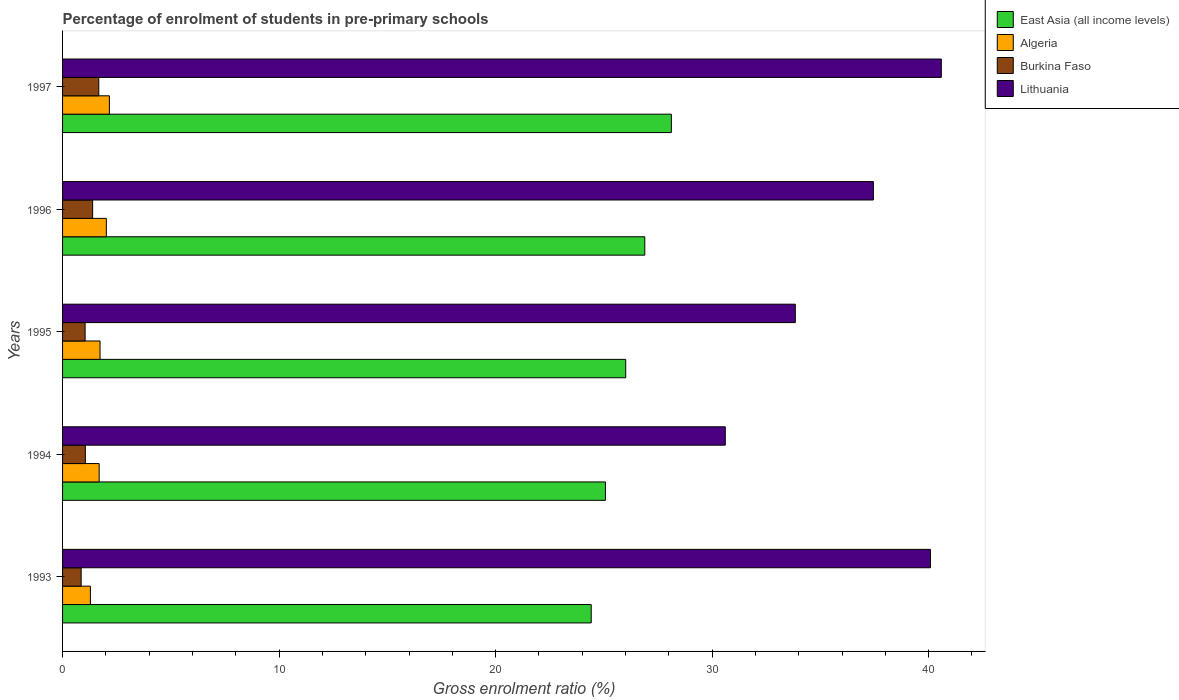How many bars are there on the 1st tick from the top?
Offer a terse response. 4. How many bars are there on the 1st tick from the bottom?
Make the answer very short. 4. What is the label of the 4th group of bars from the top?
Offer a terse response. 1994. In how many cases, is the number of bars for a given year not equal to the number of legend labels?
Offer a very short reply. 0. What is the percentage of students enrolled in pre-primary schools in Burkina Faso in 1994?
Make the answer very short. 1.05. Across all years, what is the maximum percentage of students enrolled in pre-primary schools in Lithuania?
Make the answer very short. 40.58. Across all years, what is the minimum percentage of students enrolled in pre-primary schools in Algeria?
Your response must be concise. 1.29. What is the total percentage of students enrolled in pre-primary schools in Lithuania in the graph?
Make the answer very short. 182.56. What is the difference between the percentage of students enrolled in pre-primary schools in Lithuania in 1995 and that in 1996?
Ensure brevity in your answer.  -3.61. What is the difference between the percentage of students enrolled in pre-primary schools in Algeria in 1996 and the percentage of students enrolled in pre-primary schools in Burkina Faso in 1997?
Offer a terse response. 0.35. What is the average percentage of students enrolled in pre-primary schools in Algeria per year?
Keep it short and to the point. 1.78. In the year 1994, what is the difference between the percentage of students enrolled in pre-primary schools in Burkina Faso and percentage of students enrolled in pre-primary schools in Algeria?
Your answer should be very brief. -0.64. What is the ratio of the percentage of students enrolled in pre-primary schools in Burkina Faso in 1995 to that in 1996?
Keep it short and to the point. 0.75. Is the percentage of students enrolled in pre-primary schools in Lithuania in 1994 less than that in 1996?
Give a very brief answer. Yes. Is the difference between the percentage of students enrolled in pre-primary schools in Burkina Faso in 1995 and 1997 greater than the difference between the percentage of students enrolled in pre-primary schools in Algeria in 1995 and 1997?
Your answer should be compact. No. What is the difference between the highest and the second highest percentage of students enrolled in pre-primary schools in Algeria?
Keep it short and to the point. 0.14. What is the difference between the highest and the lowest percentage of students enrolled in pre-primary schools in Lithuania?
Your response must be concise. 9.98. In how many years, is the percentage of students enrolled in pre-primary schools in Lithuania greater than the average percentage of students enrolled in pre-primary schools in Lithuania taken over all years?
Give a very brief answer. 3. Is the sum of the percentage of students enrolled in pre-primary schools in Burkina Faso in 1994 and 1995 greater than the maximum percentage of students enrolled in pre-primary schools in East Asia (all income levels) across all years?
Provide a succinct answer. No. What does the 3rd bar from the top in 1996 represents?
Ensure brevity in your answer.  Algeria. What does the 3rd bar from the bottom in 1994 represents?
Offer a very short reply. Burkina Faso. How many bars are there?
Give a very brief answer. 20. Does the graph contain any zero values?
Your answer should be very brief. No. Does the graph contain grids?
Your answer should be very brief. No. What is the title of the graph?
Your answer should be very brief. Percentage of enrolment of students in pre-primary schools. What is the Gross enrolment ratio (%) of East Asia (all income levels) in 1993?
Provide a succinct answer. 24.42. What is the Gross enrolment ratio (%) of Algeria in 1993?
Your answer should be very brief. 1.29. What is the Gross enrolment ratio (%) of Burkina Faso in 1993?
Your response must be concise. 0.86. What is the Gross enrolment ratio (%) in Lithuania in 1993?
Keep it short and to the point. 40.08. What is the Gross enrolment ratio (%) in East Asia (all income levels) in 1994?
Offer a very short reply. 25.07. What is the Gross enrolment ratio (%) in Algeria in 1994?
Your response must be concise. 1.69. What is the Gross enrolment ratio (%) in Burkina Faso in 1994?
Your answer should be very brief. 1.05. What is the Gross enrolment ratio (%) of Lithuania in 1994?
Offer a terse response. 30.61. What is the Gross enrolment ratio (%) in East Asia (all income levels) in 1995?
Provide a succinct answer. 26.01. What is the Gross enrolment ratio (%) in Algeria in 1995?
Give a very brief answer. 1.73. What is the Gross enrolment ratio (%) in Burkina Faso in 1995?
Your answer should be compact. 1.04. What is the Gross enrolment ratio (%) in Lithuania in 1995?
Provide a short and direct response. 33.84. What is the Gross enrolment ratio (%) in East Asia (all income levels) in 1996?
Provide a short and direct response. 26.89. What is the Gross enrolment ratio (%) of Algeria in 1996?
Provide a short and direct response. 2.02. What is the Gross enrolment ratio (%) of Burkina Faso in 1996?
Your answer should be compact. 1.39. What is the Gross enrolment ratio (%) of Lithuania in 1996?
Your answer should be very brief. 37.45. What is the Gross enrolment ratio (%) in East Asia (all income levels) in 1997?
Give a very brief answer. 28.12. What is the Gross enrolment ratio (%) in Algeria in 1997?
Offer a very short reply. 2.16. What is the Gross enrolment ratio (%) in Burkina Faso in 1997?
Offer a very short reply. 1.67. What is the Gross enrolment ratio (%) in Lithuania in 1997?
Provide a succinct answer. 40.58. Across all years, what is the maximum Gross enrolment ratio (%) of East Asia (all income levels)?
Provide a succinct answer. 28.12. Across all years, what is the maximum Gross enrolment ratio (%) of Algeria?
Make the answer very short. 2.16. Across all years, what is the maximum Gross enrolment ratio (%) in Burkina Faso?
Give a very brief answer. 1.67. Across all years, what is the maximum Gross enrolment ratio (%) of Lithuania?
Make the answer very short. 40.58. Across all years, what is the minimum Gross enrolment ratio (%) of East Asia (all income levels)?
Offer a terse response. 24.42. Across all years, what is the minimum Gross enrolment ratio (%) of Algeria?
Offer a terse response. 1.29. Across all years, what is the minimum Gross enrolment ratio (%) in Burkina Faso?
Offer a terse response. 0.86. Across all years, what is the minimum Gross enrolment ratio (%) of Lithuania?
Keep it short and to the point. 30.61. What is the total Gross enrolment ratio (%) in East Asia (all income levels) in the graph?
Give a very brief answer. 130.5. What is the total Gross enrolment ratio (%) of Algeria in the graph?
Your answer should be very brief. 8.89. What is the total Gross enrolment ratio (%) in Burkina Faso in the graph?
Give a very brief answer. 6.01. What is the total Gross enrolment ratio (%) in Lithuania in the graph?
Your answer should be compact. 182.56. What is the difference between the Gross enrolment ratio (%) of East Asia (all income levels) in 1993 and that in 1994?
Your answer should be very brief. -0.66. What is the difference between the Gross enrolment ratio (%) of Algeria in 1993 and that in 1994?
Your answer should be compact. -0.4. What is the difference between the Gross enrolment ratio (%) of Burkina Faso in 1993 and that in 1994?
Keep it short and to the point. -0.19. What is the difference between the Gross enrolment ratio (%) in Lithuania in 1993 and that in 1994?
Provide a succinct answer. 9.48. What is the difference between the Gross enrolment ratio (%) of East Asia (all income levels) in 1993 and that in 1995?
Provide a succinct answer. -1.59. What is the difference between the Gross enrolment ratio (%) of Algeria in 1993 and that in 1995?
Keep it short and to the point. -0.44. What is the difference between the Gross enrolment ratio (%) in Burkina Faso in 1993 and that in 1995?
Provide a short and direct response. -0.18. What is the difference between the Gross enrolment ratio (%) in Lithuania in 1993 and that in 1995?
Make the answer very short. 6.24. What is the difference between the Gross enrolment ratio (%) in East Asia (all income levels) in 1993 and that in 1996?
Ensure brevity in your answer.  -2.47. What is the difference between the Gross enrolment ratio (%) of Algeria in 1993 and that in 1996?
Provide a short and direct response. -0.74. What is the difference between the Gross enrolment ratio (%) in Burkina Faso in 1993 and that in 1996?
Offer a terse response. -0.53. What is the difference between the Gross enrolment ratio (%) of Lithuania in 1993 and that in 1996?
Offer a terse response. 2.63. What is the difference between the Gross enrolment ratio (%) in East Asia (all income levels) in 1993 and that in 1997?
Keep it short and to the point. -3.7. What is the difference between the Gross enrolment ratio (%) of Algeria in 1993 and that in 1997?
Provide a succinct answer. -0.88. What is the difference between the Gross enrolment ratio (%) of Burkina Faso in 1993 and that in 1997?
Offer a terse response. -0.81. What is the difference between the Gross enrolment ratio (%) in Lithuania in 1993 and that in 1997?
Make the answer very short. -0.5. What is the difference between the Gross enrolment ratio (%) of East Asia (all income levels) in 1994 and that in 1995?
Offer a very short reply. -0.94. What is the difference between the Gross enrolment ratio (%) of Algeria in 1994 and that in 1995?
Give a very brief answer. -0.04. What is the difference between the Gross enrolment ratio (%) of Burkina Faso in 1994 and that in 1995?
Make the answer very short. 0.01. What is the difference between the Gross enrolment ratio (%) in Lithuania in 1994 and that in 1995?
Offer a terse response. -3.23. What is the difference between the Gross enrolment ratio (%) of East Asia (all income levels) in 1994 and that in 1996?
Offer a terse response. -1.82. What is the difference between the Gross enrolment ratio (%) of Algeria in 1994 and that in 1996?
Your response must be concise. -0.33. What is the difference between the Gross enrolment ratio (%) of Burkina Faso in 1994 and that in 1996?
Provide a short and direct response. -0.34. What is the difference between the Gross enrolment ratio (%) in Lithuania in 1994 and that in 1996?
Offer a terse response. -6.84. What is the difference between the Gross enrolment ratio (%) of East Asia (all income levels) in 1994 and that in 1997?
Offer a very short reply. -3.04. What is the difference between the Gross enrolment ratio (%) in Algeria in 1994 and that in 1997?
Keep it short and to the point. -0.47. What is the difference between the Gross enrolment ratio (%) in Burkina Faso in 1994 and that in 1997?
Your response must be concise. -0.62. What is the difference between the Gross enrolment ratio (%) of Lithuania in 1994 and that in 1997?
Your answer should be compact. -9.98. What is the difference between the Gross enrolment ratio (%) in East Asia (all income levels) in 1995 and that in 1996?
Provide a short and direct response. -0.88. What is the difference between the Gross enrolment ratio (%) of Algeria in 1995 and that in 1996?
Your answer should be very brief. -0.29. What is the difference between the Gross enrolment ratio (%) in Burkina Faso in 1995 and that in 1996?
Keep it short and to the point. -0.35. What is the difference between the Gross enrolment ratio (%) of Lithuania in 1995 and that in 1996?
Offer a very short reply. -3.61. What is the difference between the Gross enrolment ratio (%) of East Asia (all income levels) in 1995 and that in 1997?
Make the answer very short. -2.11. What is the difference between the Gross enrolment ratio (%) in Algeria in 1995 and that in 1997?
Offer a very short reply. -0.43. What is the difference between the Gross enrolment ratio (%) in Burkina Faso in 1995 and that in 1997?
Your answer should be very brief. -0.63. What is the difference between the Gross enrolment ratio (%) of Lithuania in 1995 and that in 1997?
Ensure brevity in your answer.  -6.74. What is the difference between the Gross enrolment ratio (%) in East Asia (all income levels) in 1996 and that in 1997?
Ensure brevity in your answer.  -1.23. What is the difference between the Gross enrolment ratio (%) of Algeria in 1996 and that in 1997?
Your answer should be very brief. -0.14. What is the difference between the Gross enrolment ratio (%) in Burkina Faso in 1996 and that in 1997?
Your answer should be very brief. -0.28. What is the difference between the Gross enrolment ratio (%) of Lithuania in 1996 and that in 1997?
Give a very brief answer. -3.14. What is the difference between the Gross enrolment ratio (%) of East Asia (all income levels) in 1993 and the Gross enrolment ratio (%) of Algeria in 1994?
Provide a short and direct response. 22.73. What is the difference between the Gross enrolment ratio (%) of East Asia (all income levels) in 1993 and the Gross enrolment ratio (%) of Burkina Faso in 1994?
Ensure brevity in your answer.  23.36. What is the difference between the Gross enrolment ratio (%) of East Asia (all income levels) in 1993 and the Gross enrolment ratio (%) of Lithuania in 1994?
Your answer should be compact. -6.19. What is the difference between the Gross enrolment ratio (%) in Algeria in 1993 and the Gross enrolment ratio (%) in Burkina Faso in 1994?
Give a very brief answer. 0.23. What is the difference between the Gross enrolment ratio (%) of Algeria in 1993 and the Gross enrolment ratio (%) of Lithuania in 1994?
Offer a very short reply. -29.32. What is the difference between the Gross enrolment ratio (%) in Burkina Faso in 1993 and the Gross enrolment ratio (%) in Lithuania in 1994?
Give a very brief answer. -29.75. What is the difference between the Gross enrolment ratio (%) of East Asia (all income levels) in 1993 and the Gross enrolment ratio (%) of Algeria in 1995?
Make the answer very short. 22.69. What is the difference between the Gross enrolment ratio (%) in East Asia (all income levels) in 1993 and the Gross enrolment ratio (%) in Burkina Faso in 1995?
Keep it short and to the point. 23.37. What is the difference between the Gross enrolment ratio (%) of East Asia (all income levels) in 1993 and the Gross enrolment ratio (%) of Lithuania in 1995?
Make the answer very short. -9.43. What is the difference between the Gross enrolment ratio (%) of Algeria in 1993 and the Gross enrolment ratio (%) of Burkina Faso in 1995?
Your answer should be compact. 0.24. What is the difference between the Gross enrolment ratio (%) of Algeria in 1993 and the Gross enrolment ratio (%) of Lithuania in 1995?
Your answer should be compact. -32.56. What is the difference between the Gross enrolment ratio (%) in Burkina Faso in 1993 and the Gross enrolment ratio (%) in Lithuania in 1995?
Keep it short and to the point. -32.98. What is the difference between the Gross enrolment ratio (%) in East Asia (all income levels) in 1993 and the Gross enrolment ratio (%) in Algeria in 1996?
Provide a short and direct response. 22.39. What is the difference between the Gross enrolment ratio (%) of East Asia (all income levels) in 1993 and the Gross enrolment ratio (%) of Burkina Faso in 1996?
Your answer should be very brief. 23.03. What is the difference between the Gross enrolment ratio (%) in East Asia (all income levels) in 1993 and the Gross enrolment ratio (%) in Lithuania in 1996?
Give a very brief answer. -13.03. What is the difference between the Gross enrolment ratio (%) of Algeria in 1993 and the Gross enrolment ratio (%) of Burkina Faso in 1996?
Ensure brevity in your answer.  -0.1. What is the difference between the Gross enrolment ratio (%) in Algeria in 1993 and the Gross enrolment ratio (%) in Lithuania in 1996?
Give a very brief answer. -36.16. What is the difference between the Gross enrolment ratio (%) of Burkina Faso in 1993 and the Gross enrolment ratio (%) of Lithuania in 1996?
Offer a very short reply. -36.59. What is the difference between the Gross enrolment ratio (%) of East Asia (all income levels) in 1993 and the Gross enrolment ratio (%) of Algeria in 1997?
Give a very brief answer. 22.25. What is the difference between the Gross enrolment ratio (%) of East Asia (all income levels) in 1993 and the Gross enrolment ratio (%) of Burkina Faso in 1997?
Make the answer very short. 22.74. What is the difference between the Gross enrolment ratio (%) of East Asia (all income levels) in 1993 and the Gross enrolment ratio (%) of Lithuania in 1997?
Your answer should be very brief. -16.17. What is the difference between the Gross enrolment ratio (%) of Algeria in 1993 and the Gross enrolment ratio (%) of Burkina Faso in 1997?
Offer a terse response. -0.39. What is the difference between the Gross enrolment ratio (%) of Algeria in 1993 and the Gross enrolment ratio (%) of Lithuania in 1997?
Provide a short and direct response. -39.3. What is the difference between the Gross enrolment ratio (%) of Burkina Faso in 1993 and the Gross enrolment ratio (%) of Lithuania in 1997?
Give a very brief answer. -39.73. What is the difference between the Gross enrolment ratio (%) in East Asia (all income levels) in 1994 and the Gross enrolment ratio (%) in Algeria in 1995?
Ensure brevity in your answer.  23.34. What is the difference between the Gross enrolment ratio (%) in East Asia (all income levels) in 1994 and the Gross enrolment ratio (%) in Burkina Faso in 1995?
Keep it short and to the point. 24.03. What is the difference between the Gross enrolment ratio (%) in East Asia (all income levels) in 1994 and the Gross enrolment ratio (%) in Lithuania in 1995?
Provide a succinct answer. -8.77. What is the difference between the Gross enrolment ratio (%) of Algeria in 1994 and the Gross enrolment ratio (%) of Burkina Faso in 1995?
Offer a very short reply. 0.65. What is the difference between the Gross enrolment ratio (%) in Algeria in 1994 and the Gross enrolment ratio (%) in Lithuania in 1995?
Keep it short and to the point. -32.15. What is the difference between the Gross enrolment ratio (%) of Burkina Faso in 1994 and the Gross enrolment ratio (%) of Lithuania in 1995?
Offer a terse response. -32.79. What is the difference between the Gross enrolment ratio (%) in East Asia (all income levels) in 1994 and the Gross enrolment ratio (%) in Algeria in 1996?
Keep it short and to the point. 23.05. What is the difference between the Gross enrolment ratio (%) in East Asia (all income levels) in 1994 and the Gross enrolment ratio (%) in Burkina Faso in 1996?
Your answer should be compact. 23.68. What is the difference between the Gross enrolment ratio (%) of East Asia (all income levels) in 1994 and the Gross enrolment ratio (%) of Lithuania in 1996?
Offer a terse response. -12.38. What is the difference between the Gross enrolment ratio (%) in Algeria in 1994 and the Gross enrolment ratio (%) in Burkina Faso in 1996?
Your response must be concise. 0.3. What is the difference between the Gross enrolment ratio (%) of Algeria in 1994 and the Gross enrolment ratio (%) of Lithuania in 1996?
Ensure brevity in your answer.  -35.76. What is the difference between the Gross enrolment ratio (%) in Burkina Faso in 1994 and the Gross enrolment ratio (%) in Lithuania in 1996?
Provide a short and direct response. -36.4. What is the difference between the Gross enrolment ratio (%) in East Asia (all income levels) in 1994 and the Gross enrolment ratio (%) in Algeria in 1997?
Offer a very short reply. 22.91. What is the difference between the Gross enrolment ratio (%) of East Asia (all income levels) in 1994 and the Gross enrolment ratio (%) of Burkina Faso in 1997?
Give a very brief answer. 23.4. What is the difference between the Gross enrolment ratio (%) in East Asia (all income levels) in 1994 and the Gross enrolment ratio (%) in Lithuania in 1997?
Offer a terse response. -15.51. What is the difference between the Gross enrolment ratio (%) in Algeria in 1994 and the Gross enrolment ratio (%) in Burkina Faso in 1997?
Your response must be concise. 0.02. What is the difference between the Gross enrolment ratio (%) in Algeria in 1994 and the Gross enrolment ratio (%) in Lithuania in 1997?
Your response must be concise. -38.89. What is the difference between the Gross enrolment ratio (%) in Burkina Faso in 1994 and the Gross enrolment ratio (%) in Lithuania in 1997?
Make the answer very short. -39.53. What is the difference between the Gross enrolment ratio (%) of East Asia (all income levels) in 1995 and the Gross enrolment ratio (%) of Algeria in 1996?
Make the answer very short. 23.99. What is the difference between the Gross enrolment ratio (%) in East Asia (all income levels) in 1995 and the Gross enrolment ratio (%) in Burkina Faso in 1996?
Give a very brief answer. 24.62. What is the difference between the Gross enrolment ratio (%) in East Asia (all income levels) in 1995 and the Gross enrolment ratio (%) in Lithuania in 1996?
Offer a very short reply. -11.44. What is the difference between the Gross enrolment ratio (%) of Algeria in 1995 and the Gross enrolment ratio (%) of Burkina Faso in 1996?
Provide a succinct answer. 0.34. What is the difference between the Gross enrolment ratio (%) in Algeria in 1995 and the Gross enrolment ratio (%) in Lithuania in 1996?
Provide a succinct answer. -35.72. What is the difference between the Gross enrolment ratio (%) in Burkina Faso in 1995 and the Gross enrolment ratio (%) in Lithuania in 1996?
Keep it short and to the point. -36.41. What is the difference between the Gross enrolment ratio (%) of East Asia (all income levels) in 1995 and the Gross enrolment ratio (%) of Algeria in 1997?
Your answer should be compact. 23.85. What is the difference between the Gross enrolment ratio (%) of East Asia (all income levels) in 1995 and the Gross enrolment ratio (%) of Burkina Faso in 1997?
Provide a succinct answer. 24.34. What is the difference between the Gross enrolment ratio (%) of East Asia (all income levels) in 1995 and the Gross enrolment ratio (%) of Lithuania in 1997?
Your response must be concise. -14.58. What is the difference between the Gross enrolment ratio (%) of Algeria in 1995 and the Gross enrolment ratio (%) of Burkina Faso in 1997?
Provide a short and direct response. 0.06. What is the difference between the Gross enrolment ratio (%) in Algeria in 1995 and the Gross enrolment ratio (%) in Lithuania in 1997?
Your answer should be compact. -38.85. What is the difference between the Gross enrolment ratio (%) of Burkina Faso in 1995 and the Gross enrolment ratio (%) of Lithuania in 1997?
Provide a succinct answer. -39.54. What is the difference between the Gross enrolment ratio (%) in East Asia (all income levels) in 1996 and the Gross enrolment ratio (%) in Algeria in 1997?
Provide a succinct answer. 24.73. What is the difference between the Gross enrolment ratio (%) in East Asia (all income levels) in 1996 and the Gross enrolment ratio (%) in Burkina Faso in 1997?
Ensure brevity in your answer.  25.22. What is the difference between the Gross enrolment ratio (%) in East Asia (all income levels) in 1996 and the Gross enrolment ratio (%) in Lithuania in 1997?
Offer a terse response. -13.69. What is the difference between the Gross enrolment ratio (%) of Algeria in 1996 and the Gross enrolment ratio (%) of Burkina Faso in 1997?
Offer a terse response. 0.35. What is the difference between the Gross enrolment ratio (%) of Algeria in 1996 and the Gross enrolment ratio (%) of Lithuania in 1997?
Ensure brevity in your answer.  -38.56. What is the difference between the Gross enrolment ratio (%) in Burkina Faso in 1996 and the Gross enrolment ratio (%) in Lithuania in 1997?
Offer a terse response. -39.2. What is the average Gross enrolment ratio (%) of East Asia (all income levels) per year?
Your answer should be compact. 26.1. What is the average Gross enrolment ratio (%) of Algeria per year?
Offer a very short reply. 1.78. What is the average Gross enrolment ratio (%) of Burkina Faso per year?
Provide a succinct answer. 1.2. What is the average Gross enrolment ratio (%) in Lithuania per year?
Your answer should be compact. 36.51. In the year 1993, what is the difference between the Gross enrolment ratio (%) in East Asia (all income levels) and Gross enrolment ratio (%) in Algeria?
Your answer should be very brief. 23.13. In the year 1993, what is the difference between the Gross enrolment ratio (%) in East Asia (all income levels) and Gross enrolment ratio (%) in Burkina Faso?
Offer a terse response. 23.56. In the year 1993, what is the difference between the Gross enrolment ratio (%) in East Asia (all income levels) and Gross enrolment ratio (%) in Lithuania?
Ensure brevity in your answer.  -15.67. In the year 1993, what is the difference between the Gross enrolment ratio (%) in Algeria and Gross enrolment ratio (%) in Burkina Faso?
Give a very brief answer. 0.43. In the year 1993, what is the difference between the Gross enrolment ratio (%) in Algeria and Gross enrolment ratio (%) in Lithuania?
Your answer should be very brief. -38.8. In the year 1993, what is the difference between the Gross enrolment ratio (%) in Burkina Faso and Gross enrolment ratio (%) in Lithuania?
Keep it short and to the point. -39.22. In the year 1994, what is the difference between the Gross enrolment ratio (%) of East Asia (all income levels) and Gross enrolment ratio (%) of Algeria?
Your answer should be very brief. 23.38. In the year 1994, what is the difference between the Gross enrolment ratio (%) of East Asia (all income levels) and Gross enrolment ratio (%) of Burkina Faso?
Your response must be concise. 24.02. In the year 1994, what is the difference between the Gross enrolment ratio (%) of East Asia (all income levels) and Gross enrolment ratio (%) of Lithuania?
Provide a succinct answer. -5.54. In the year 1994, what is the difference between the Gross enrolment ratio (%) of Algeria and Gross enrolment ratio (%) of Burkina Faso?
Your response must be concise. 0.64. In the year 1994, what is the difference between the Gross enrolment ratio (%) of Algeria and Gross enrolment ratio (%) of Lithuania?
Provide a succinct answer. -28.92. In the year 1994, what is the difference between the Gross enrolment ratio (%) of Burkina Faso and Gross enrolment ratio (%) of Lithuania?
Ensure brevity in your answer.  -29.56. In the year 1995, what is the difference between the Gross enrolment ratio (%) of East Asia (all income levels) and Gross enrolment ratio (%) of Algeria?
Provide a succinct answer. 24.28. In the year 1995, what is the difference between the Gross enrolment ratio (%) in East Asia (all income levels) and Gross enrolment ratio (%) in Burkina Faso?
Ensure brevity in your answer.  24.97. In the year 1995, what is the difference between the Gross enrolment ratio (%) in East Asia (all income levels) and Gross enrolment ratio (%) in Lithuania?
Provide a succinct answer. -7.83. In the year 1995, what is the difference between the Gross enrolment ratio (%) of Algeria and Gross enrolment ratio (%) of Burkina Faso?
Your response must be concise. 0.69. In the year 1995, what is the difference between the Gross enrolment ratio (%) of Algeria and Gross enrolment ratio (%) of Lithuania?
Make the answer very short. -32.11. In the year 1995, what is the difference between the Gross enrolment ratio (%) of Burkina Faso and Gross enrolment ratio (%) of Lithuania?
Provide a succinct answer. -32.8. In the year 1996, what is the difference between the Gross enrolment ratio (%) in East Asia (all income levels) and Gross enrolment ratio (%) in Algeria?
Your answer should be very brief. 24.87. In the year 1996, what is the difference between the Gross enrolment ratio (%) in East Asia (all income levels) and Gross enrolment ratio (%) in Burkina Faso?
Provide a short and direct response. 25.5. In the year 1996, what is the difference between the Gross enrolment ratio (%) of East Asia (all income levels) and Gross enrolment ratio (%) of Lithuania?
Ensure brevity in your answer.  -10.56. In the year 1996, what is the difference between the Gross enrolment ratio (%) in Algeria and Gross enrolment ratio (%) in Burkina Faso?
Keep it short and to the point. 0.63. In the year 1996, what is the difference between the Gross enrolment ratio (%) of Algeria and Gross enrolment ratio (%) of Lithuania?
Make the answer very short. -35.43. In the year 1996, what is the difference between the Gross enrolment ratio (%) in Burkina Faso and Gross enrolment ratio (%) in Lithuania?
Offer a very short reply. -36.06. In the year 1997, what is the difference between the Gross enrolment ratio (%) of East Asia (all income levels) and Gross enrolment ratio (%) of Algeria?
Your answer should be compact. 25.95. In the year 1997, what is the difference between the Gross enrolment ratio (%) of East Asia (all income levels) and Gross enrolment ratio (%) of Burkina Faso?
Your answer should be very brief. 26.44. In the year 1997, what is the difference between the Gross enrolment ratio (%) of East Asia (all income levels) and Gross enrolment ratio (%) of Lithuania?
Your response must be concise. -12.47. In the year 1997, what is the difference between the Gross enrolment ratio (%) in Algeria and Gross enrolment ratio (%) in Burkina Faso?
Offer a very short reply. 0.49. In the year 1997, what is the difference between the Gross enrolment ratio (%) of Algeria and Gross enrolment ratio (%) of Lithuania?
Ensure brevity in your answer.  -38.42. In the year 1997, what is the difference between the Gross enrolment ratio (%) in Burkina Faso and Gross enrolment ratio (%) in Lithuania?
Keep it short and to the point. -38.91. What is the ratio of the Gross enrolment ratio (%) of East Asia (all income levels) in 1993 to that in 1994?
Provide a succinct answer. 0.97. What is the ratio of the Gross enrolment ratio (%) of Algeria in 1993 to that in 1994?
Make the answer very short. 0.76. What is the ratio of the Gross enrolment ratio (%) of Burkina Faso in 1993 to that in 1994?
Your response must be concise. 0.82. What is the ratio of the Gross enrolment ratio (%) in Lithuania in 1993 to that in 1994?
Keep it short and to the point. 1.31. What is the ratio of the Gross enrolment ratio (%) of East Asia (all income levels) in 1993 to that in 1995?
Keep it short and to the point. 0.94. What is the ratio of the Gross enrolment ratio (%) of Algeria in 1993 to that in 1995?
Your answer should be compact. 0.74. What is the ratio of the Gross enrolment ratio (%) in Burkina Faso in 1993 to that in 1995?
Your answer should be compact. 0.82. What is the ratio of the Gross enrolment ratio (%) in Lithuania in 1993 to that in 1995?
Give a very brief answer. 1.18. What is the ratio of the Gross enrolment ratio (%) of East Asia (all income levels) in 1993 to that in 1996?
Offer a terse response. 0.91. What is the ratio of the Gross enrolment ratio (%) in Algeria in 1993 to that in 1996?
Provide a short and direct response. 0.64. What is the ratio of the Gross enrolment ratio (%) of Burkina Faso in 1993 to that in 1996?
Offer a very short reply. 0.62. What is the ratio of the Gross enrolment ratio (%) of Lithuania in 1993 to that in 1996?
Your answer should be compact. 1.07. What is the ratio of the Gross enrolment ratio (%) in East Asia (all income levels) in 1993 to that in 1997?
Your answer should be very brief. 0.87. What is the ratio of the Gross enrolment ratio (%) of Algeria in 1993 to that in 1997?
Provide a short and direct response. 0.59. What is the ratio of the Gross enrolment ratio (%) in Burkina Faso in 1993 to that in 1997?
Provide a short and direct response. 0.51. What is the ratio of the Gross enrolment ratio (%) of Lithuania in 1993 to that in 1997?
Offer a very short reply. 0.99. What is the ratio of the Gross enrolment ratio (%) of East Asia (all income levels) in 1994 to that in 1995?
Make the answer very short. 0.96. What is the ratio of the Gross enrolment ratio (%) of Algeria in 1994 to that in 1995?
Provide a short and direct response. 0.98. What is the ratio of the Gross enrolment ratio (%) in Burkina Faso in 1994 to that in 1995?
Provide a succinct answer. 1.01. What is the ratio of the Gross enrolment ratio (%) of Lithuania in 1994 to that in 1995?
Provide a short and direct response. 0.9. What is the ratio of the Gross enrolment ratio (%) of East Asia (all income levels) in 1994 to that in 1996?
Keep it short and to the point. 0.93. What is the ratio of the Gross enrolment ratio (%) of Algeria in 1994 to that in 1996?
Offer a terse response. 0.84. What is the ratio of the Gross enrolment ratio (%) of Burkina Faso in 1994 to that in 1996?
Offer a very short reply. 0.76. What is the ratio of the Gross enrolment ratio (%) in Lithuania in 1994 to that in 1996?
Your response must be concise. 0.82. What is the ratio of the Gross enrolment ratio (%) of East Asia (all income levels) in 1994 to that in 1997?
Provide a short and direct response. 0.89. What is the ratio of the Gross enrolment ratio (%) in Algeria in 1994 to that in 1997?
Make the answer very short. 0.78. What is the ratio of the Gross enrolment ratio (%) of Burkina Faso in 1994 to that in 1997?
Provide a short and direct response. 0.63. What is the ratio of the Gross enrolment ratio (%) of Lithuania in 1994 to that in 1997?
Your response must be concise. 0.75. What is the ratio of the Gross enrolment ratio (%) in East Asia (all income levels) in 1995 to that in 1996?
Your response must be concise. 0.97. What is the ratio of the Gross enrolment ratio (%) in Algeria in 1995 to that in 1996?
Your response must be concise. 0.86. What is the ratio of the Gross enrolment ratio (%) in Burkina Faso in 1995 to that in 1996?
Your answer should be compact. 0.75. What is the ratio of the Gross enrolment ratio (%) of Lithuania in 1995 to that in 1996?
Provide a short and direct response. 0.9. What is the ratio of the Gross enrolment ratio (%) of East Asia (all income levels) in 1995 to that in 1997?
Offer a very short reply. 0.93. What is the ratio of the Gross enrolment ratio (%) of Algeria in 1995 to that in 1997?
Offer a very short reply. 0.8. What is the ratio of the Gross enrolment ratio (%) in Burkina Faso in 1995 to that in 1997?
Keep it short and to the point. 0.62. What is the ratio of the Gross enrolment ratio (%) in Lithuania in 1995 to that in 1997?
Keep it short and to the point. 0.83. What is the ratio of the Gross enrolment ratio (%) in East Asia (all income levels) in 1996 to that in 1997?
Make the answer very short. 0.96. What is the ratio of the Gross enrolment ratio (%) of Algeria in 1996 to that in 1997?
Your response must be concise. 0.93. What is the ratio of the Gross enrolment ratio (%) of Burkina Faso in 1996 to that in 1997?
Your answer should be compact. 0.83. What is the ratio of the Gross enrolment ratio (%) of Lithuania in 1996 to that in 1997?
Keep it short and to the point. 0.92. What is the difference between the highest and the second highest Gross enrolment ratio (%) in East Asia (all income levels)?
Offer a terse response. 1.23. What is the difference between the highest and the second highest Gross enrolment ratio (%) of Algeria?
Ensure brevity in your answer.  0.14. What is the difference between the highest and the second highest Gross enrolment ratio (%) in Burkina Faso?
Your answer should be very brief. 0.28. What is the difference between the highest and the second highest Gross enrolment ratio (%) of Lithuania?
Your answer should be very brief. 0.5. What is the difference between the highest and the lowest Gross enrolment ratio (%) of East Asia (all income levels)?
Your answer should be very brief. 3.7. What is the difference between the highest and the lowest Gross enrolment ratio (%) in Algeria?
Give a very brief answer. 0.88. What is the difference between the highest and the lowest Gross enrolment ratio (%) in Burkina Faso?
Give a very brief answer. 0.81. What is the difference between the highest and the lowest Gross enrolment ratio (%) in Lithuania?
Ensure brevity in your answer.  9.98. 